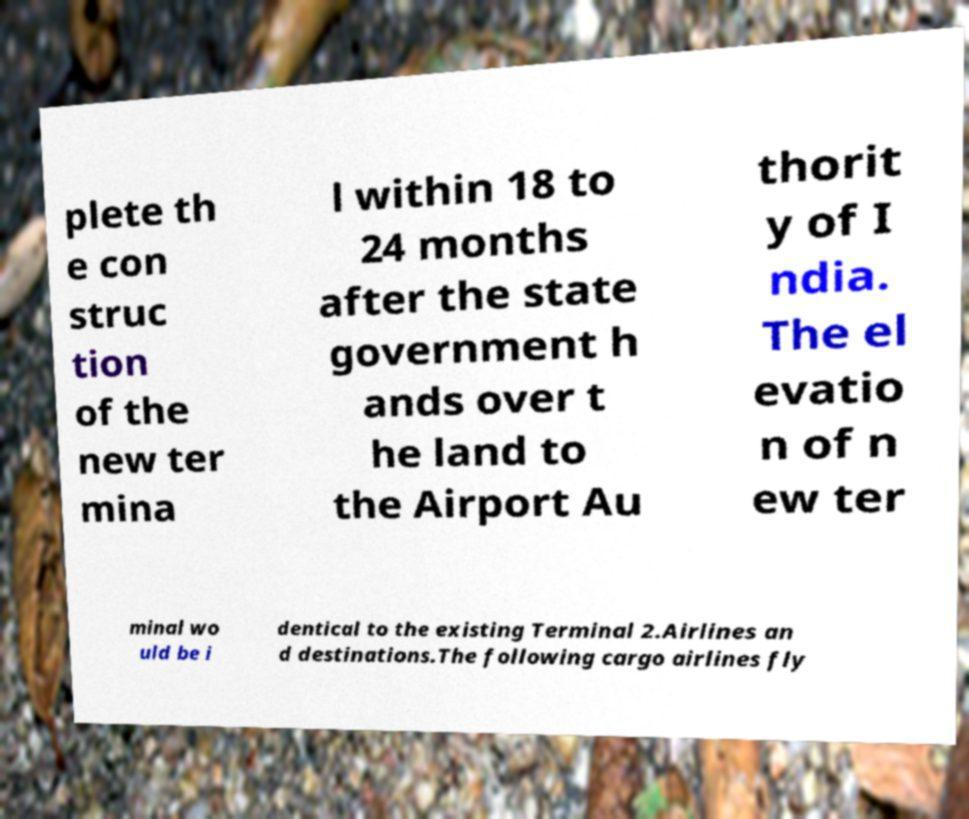What messages or text are displayed in this image? I need them in a readable, typed format. plete th e con struc tion of the new ter mina l within 18 to 24 months after the state government h ands over t he land to the Airport Au thorit y of I ndia. The el evatio n of n ew ter minal wo uld be i dentical to the existing Terminal 2.Airlines an d destinations.The following cargo airlines fly 